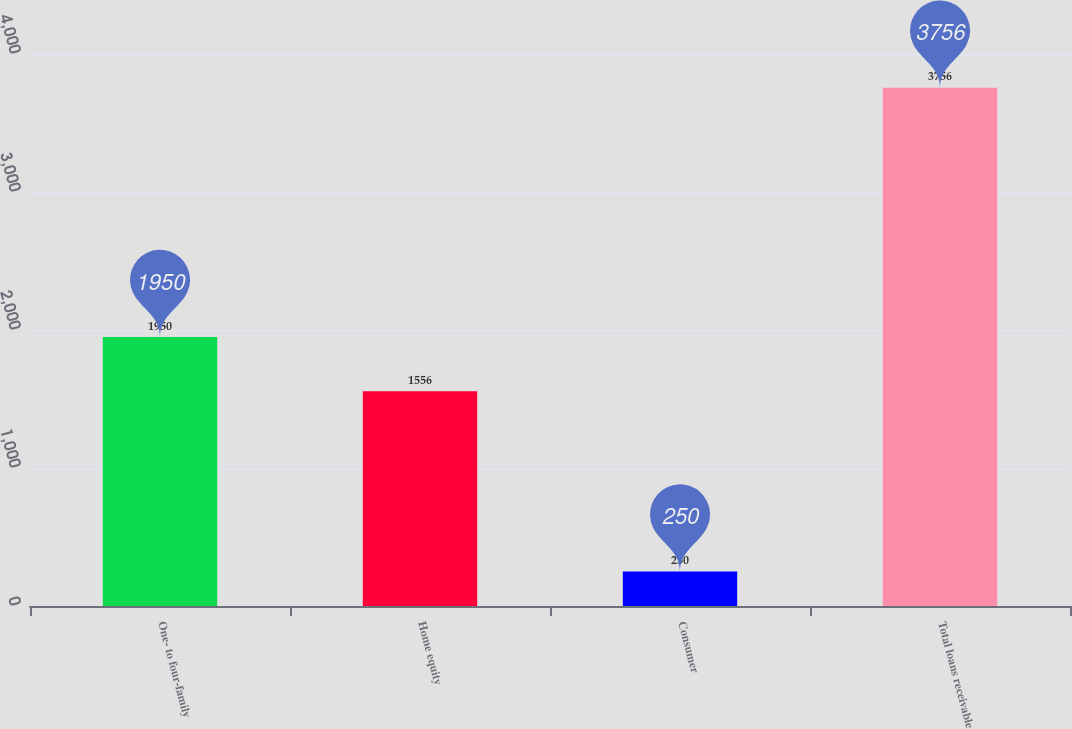<chart> <loc_0><loc_0><loc_500><loc_500><bar_chart><fcel>One- to four-family<fcel>Home equity<fcel>Consumer<fcel>Total loans receivable<nl><fcel>1950<fcel>1556<fcel>250<fcel>3756<nl></chart> 